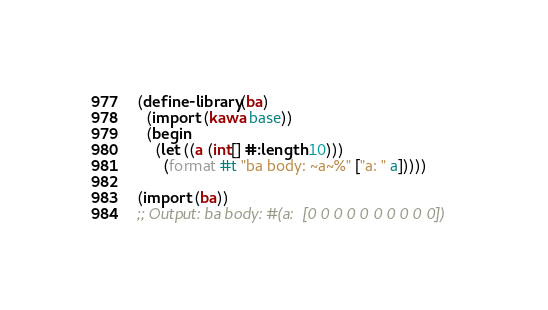Convert code to text. <code><loc_0><loc_0><loc_500><loc_500><_Scheme_>(define-library (ba)
  (import (kawa base))
  (begin
    (let ((a (int[] #:length 10)))
      (format #t "ba body: ~a~%" ["a: " a]))))

(import (ba))
;; Output: ba body: #(a:  [0 0 0 0 0 0 0 0 0 0])
</code> 